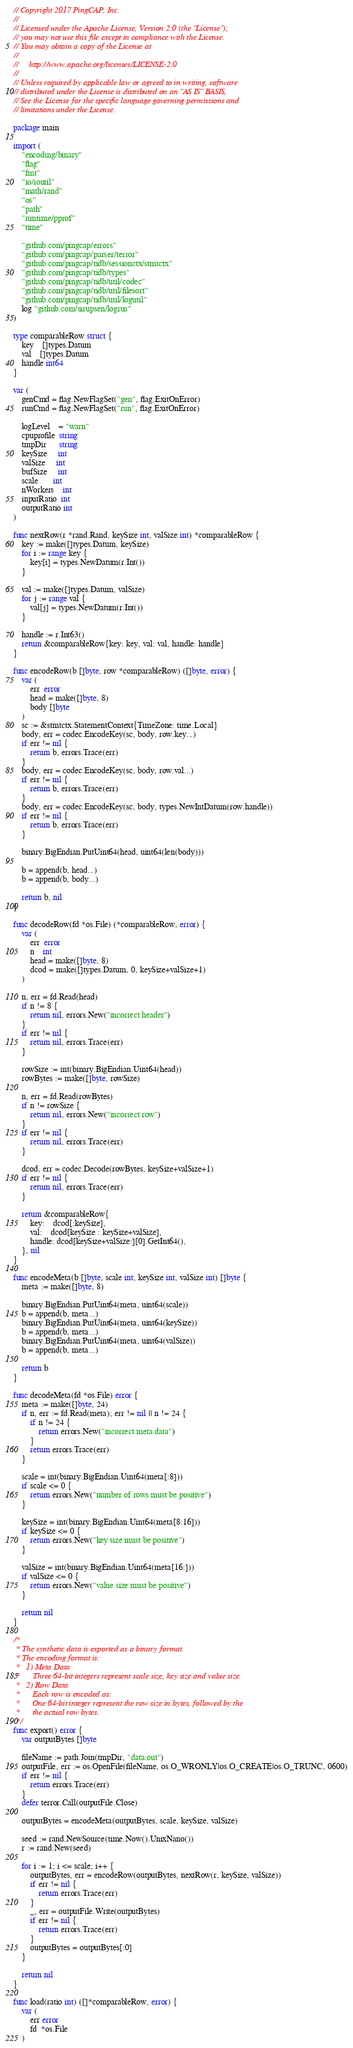<code> <loc_0><loc_0><loc_500><loc_500><_Go_>// Copyright 2017 PingCAP, Inc.
//
// Licensed under the Apache License, Version 2.0 (the "License");
// you may not use this file except in compliance with the License.
// You may obtain a copy of the License at
//
//     http://www.apache.org/licenses/LICENSE-2.0
//
// Unless required by applicable law or agreed to in writing, software
// distributed under the License is distributed on an "AS IS" BASIS,
// See the License for the specific language governing permissions and
// limitations under the License.

package main

import (
	"encoding/binary"
	"flag"
	"fmt"
	"io/ioutil"
	"math/rand"
	"os"
	"path"
	"runtime/pprof"
	"time"

	"github.com/pingcap/errors"
	"github.com/pingcap/parser/terror"
	"github.com/pingcap/tidb/sessionctx/stmtctx"
	"github.com/pingcap/tidb/types"
	"github.com/pingcap/tidb/util/codec"
	"github.com/pingcap/tidb/util/filesort"
	"github.com/pingcap/tidb/util/logutil"
	log "github.com/sirupsen/logrus"
)

type comparableRow struct {
	key    []types.Datum
	val    []types.Datum
	handle int64
}

var (
	genCmd = flag.NewFlagSet("gen", flag.ExitOnError)
	runCmd = flag.NewFlagSet("run", flag.ExitOnError)

	logLevel    = "warn"
	cpuprofile  string
	tmpDir      string
	keySize     int
	valSize     int
	bufSize     int
	scale       int
	nWorkers    int
	inputRatio  int
	outputRatio int
)

func nextRow(r *rand.Rand, keySize int, valSize int) *comparableRow {
	key := make([]types.Datum, keySize)
	for i := range key {
		key[i] = types.NewDatum(r.Int())
	}

	val := make([]types.Datum, valSize)
	for j := range val {
		val[j] = types.NewDatum(r.Int())
	}

	handle := r.Int63()
	return &comparableRow{key: key, val: val, handle: handle}
}

func encodeRow(b []byte, row *comparableRow) ([]byte, error) {
	var (
		err  error
		head = make([]byte, 8)
		body []byte
	)
	sc := &stmtctx.StatementContext{TimeZone: time.Local}
	body, err = codec.EncodeKey(sc, body, row.key...)
	if err != nil {
		return b, errors.Trace(err)
	}
	body, err = codec.EncodeKey(sc, body, row.val...)
	if err != nil {
		return b, errors.Trace(err)
	}
	body, err = codec.EncodeKey(sc, body, types.NewIntDatum(row.handle))
	if err != nil {
		return b, errors.Trace(err)
	}

	binary.BigEndian.PutUint64(head, uint64(len(body)))

	b = append(b, head...)
	b = append(b, body...)

	return b, nil
}

func decodeRow(fd *os.File) (*comparableRow, error) {
	var (
		err  error
		n    int
		head = make([]byte, 8)
		dcod = make([]types.Datum, 0, keySize+valSize+1)
	)

	n, err = fd.Read(head)
	if n != 8 {
		return nil, errors.New("incorrect header")
	}
	if err != nil {
		return nil, errors.Trace(err)
	}

	rowSize := int(binary.BigEndian.Uint64(head))
	rowBytes := make([]byte, rowSize)

	n, err = fd.Read(rowBytes)
	if n != rowSize {
		return nil, errors.New("incorrect row")
	}
	if err != nil {
		return nil, errors.Trace(err)
	}

	dcod, err = codec.Decode(rowBytes, keySize+valSize+1)
	if err != nil {
		return nil, errors.Trace(err)
	}

	return &comparableRow{
		key:    dcod[:keySize],
		val:    dcod[keySize : keySize+valSize],
		handle: dcod[keySize+valSize:][0].GetInt64(),
	}, nil
}

func encodeMeta(b []byte, scale int, keySize int, valSize int) []byte {
	meta := make([]byte, 8)

	binary.BigEndian.PutUint64(meta, uint64(scale))
	b = append(b, meta...)
	binary.BigEndian.PutUint64(meta, uint64(keySize))
	b = append(b, meta...)
	binary.BigEndian.PutUint64(meta, uint64(valSize))
	b = append(b, meta...)

	return b
}

func decodeMeta(fd *os.File) error {
	meta := make([]byte, 24)
	if n, err := fd.Read(meta); err != nil || n != 24 {
		if n != 24 {
			return errors.New("incorrect meta data")
		}
		return errors.Trace(err)
	}

	scale = int(binary.BigEndian.Uint64(meta[:8]))
	if scale <= 0 {
		return errors.New("number of rows must be positive")
	}

	keySize = int(binary.BigEndian.Uint64(meta[8:16]))
	if keySize <= 0 {
		return errors.New("key size must be positive")
	}

	valSize = int(binary.BigEndian.Uint64(meta[16:]))
	if valSize <= 0 {
		return errors.New("value size must be positive")
	}

	return nil
}

/*
 * The synthetic data is exported as a binary format.
 * The encoding format is:
 *   1) Meta Data
 *      Three 64-bit integers represent scale size, key size and value size.
 *   2) Row Data
 *      Each row is encoded as:
 *		One 64-bit integer represent the row size in bytes, followed by the
 *      the actual row bytes.
 */
func export() error {
	var outputBytes []byte

	fileName := path.Join(tmpDir, "data.out")
	outputFile, err := os.OpenFile(fileName, os.O_WRONLY|os.O_CREATE|os.O_TRUNC, 0600)
	if err != nil {
		return errors.Trace(err)
	}
	defer terror.Call(outputFile.Close)

	outputBytes = encodeMeta(outputBytes, scale, keySize, valSize)

	seed := rand.NewSource(time.Now().UnixNano())
	r := rand.New(seed)

	for i := 1; i <= scale; i++ {
		outputBytes, err = encodeRow(outputBytes, nextRow(r, keySize, valSize))
		if err != nil {
			return errors.Trace(err)
		}
		_, err = outputFile.Write(outputBytes)
		if err != nil {
			return errors.Trace(err)
		}
		outputBytes = outputBytes[:0]
	}

	return nil
}

func load(ratio int) ([]*comparableRow, error) {
	var (
		err error
		fd  *os.File
	)
</code> 